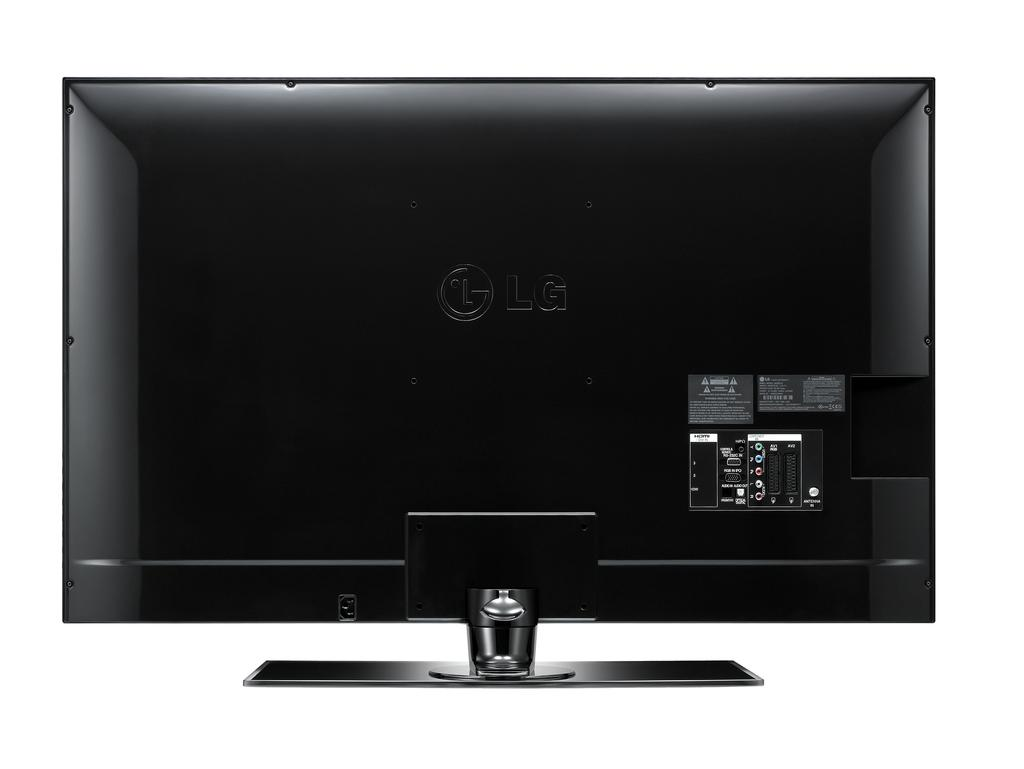<image>
Write a terse but informative summary of the picture. The back side of an LG TV that also features plug ins and warnings 